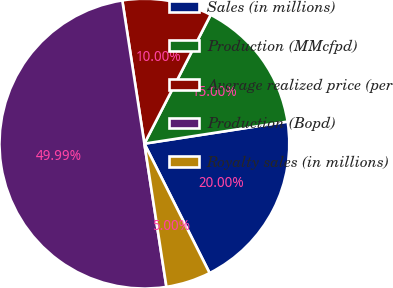<chart> <loc_0><loc_0><loc_500><loc_500><pie_chart><fcel>Sales (in millions)<fcel>Production (MMcfpd)<fcel>Average realized price (per<fcel>Production (Bopd)<fcel>Royalty sales (in millions)<nl><fcel>20.0%<fcel>15.0%<fcel>10.0%<fcel>49.99%<fcel>5.0%<nl></chart> 